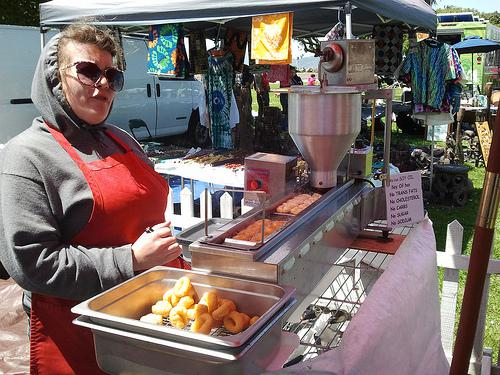Question: what color is the grass?
Choices:
A. Brown.
B. Green.
C. Yellow.
D. Grey.
Answer with the letter. Answer: B Question: what color is the woman's apron?
Choices:
A. White.
B. Black.
C. Blue.
D. Red.
Answer with the letter. Answer: D Question: where was the picture taken?
Choices:
A. At the ballgame.
B. At a market.
C. At the concert.
D. At the library.
Answer with the letter. Answer: B 